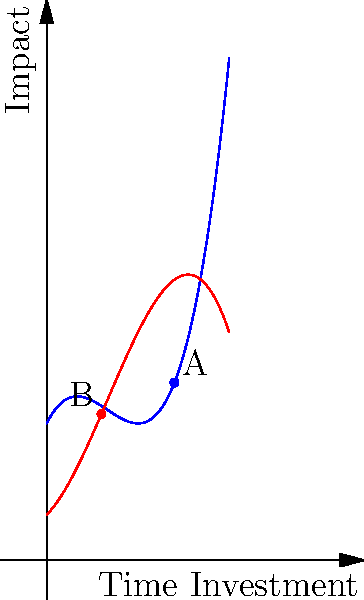The graph shows two polynomial curves representing the impact of time investment on team performance (blue) and individual stats (red) for a wide receiver. Point A on the blue curve represents focusing on team-oriented tasks, while point B on the red curve represents prioritizing individual performance. Based on the graph, which point should be prioritized to maximize overall team success, and why? To determine which point should be prioritized for maximum team success, we need to analyze the graph and compare the impacts at points A and B:

1. Identify the y-axis: It represents the impact on team success.
2. Compare y-values: 
   - Point A (on blue curve): has a higher y-value
   - Point B (on red curve): has a lower y-value
3. Interpret the curves:
   - Blue curve (Team Performance): shows a higher overall impact
   - Red curve (Individual Stats): shows a lower overall impact
4. Analyze the intersection: The blue curve is generally higher than the red curve, especially after the intersection point.
5. Consider long-term effects: The blue curve's steeper positive slope indicates a greater potential for continued improvement in team performance.
6. Conclusion: Point A should be prioritized because:
   - It has a higher immediate impact on team success
   - It aligns with the curve that shows greater long-term benefits for the team
   - Focusing on team-oriented tasks (blue curve) generally yields better results for overall team success than prioritizing individual stats (red curve)
Answer: Point A (team-oriented tasks) should be prioritized for maximum team success. 